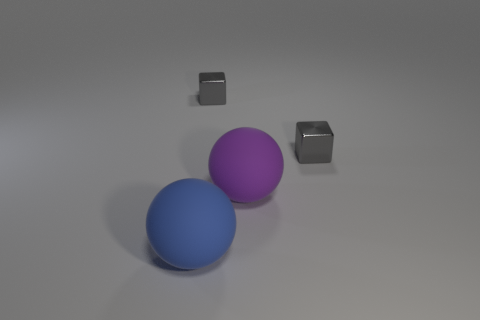Can you describe the arrangement and positioning of the objects? Certainly. There are two spheres in the center— one blue, one purple—placed close to each other. To the right, two smaller cubes sit at varying distances. The arrangement is asymmetrical, with the spheres dominating the visual field and the cubes adding a sense of balance.  If we were to categorize these objects, what categories would they fall into? These objects could be categorized based on their geometric shapes: the spheres fall into the category of round, three-dimensional objects, while the cubes belong to the angular, three-dimensional category. They could also be grouped by size, with the spheres being larger and the cubes smaller in comparison. 